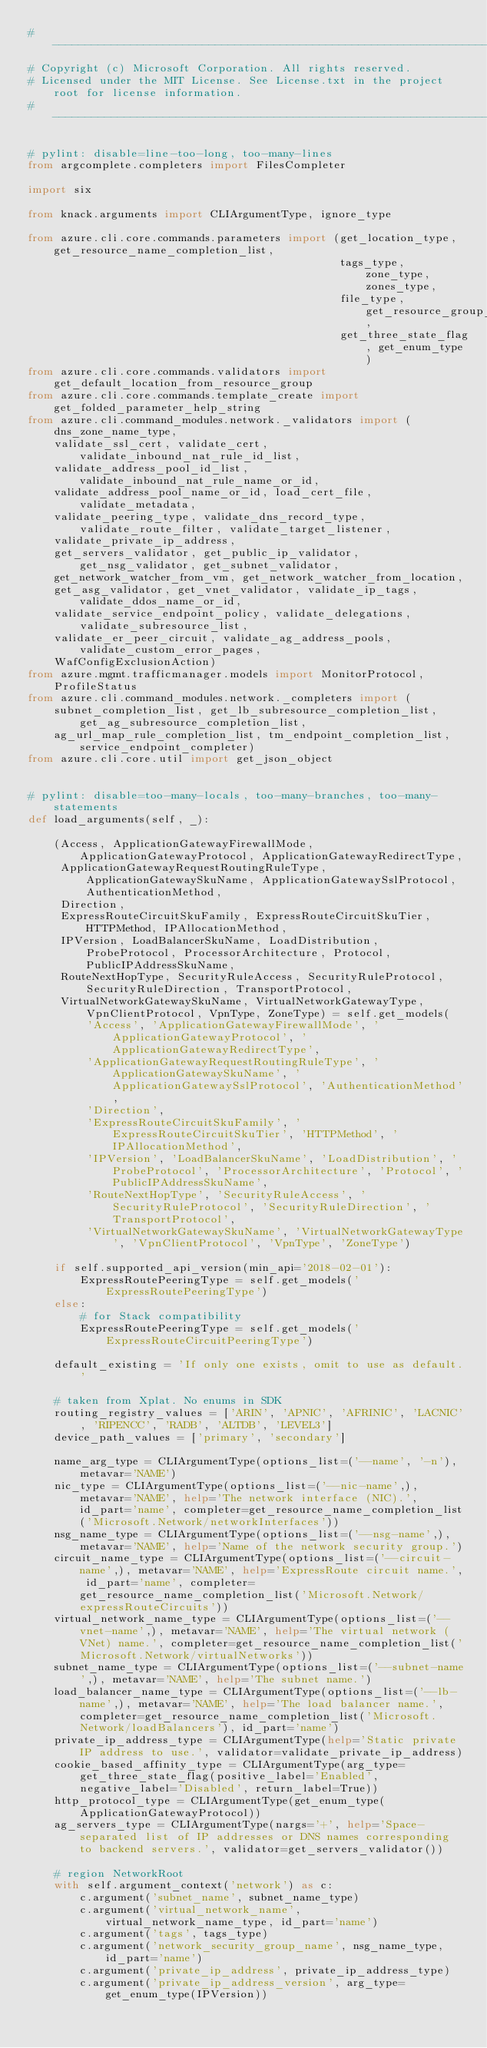Convert code to text. <code><loc_0><loc_0><loc_500><loc_500><_Python_># --------------------------------------------------------------------------------------------
# Copyright (c) Microsoft Corporation. All rights reserved.
# Licensed under the MIT License. See License.txt in the project root for license information.
# --------------------------------------------------------------------------------------------

# pylint: disable=line-too-long, too-many-lines
from argcomplete.completers import FilesCompleter

import six

from knack.arguments import CLIArgumentType, ignore_type

from azure.cli.core.commands.parameters import (get_location_type, get_resource_name_completion_list,
                                                tags_type, zone_type, zones_type,
                                                file_type, get_resource_group_completion_list,
                                                get_three_state_flag, get_enum_type)
from azure.cli.core.commands.validators import get_default_location_from_resource_group
from azure.cli.core.commands.template_create import get_folded_parameter_help_string
from azure.cli.command_modules.network._validators import (
    dns_zone_name_type,
    validate_ssl_cert, validate_cert, validate_inbound_nat_rule_id_list,
    validate_address_pool_id_list, validate_inbound_nat_rule_name_or_id,
    validate_address_pool_name_or_id, load_cert_file, validate_metadata,
    validate_peering_type, validate_dns_record_type, validate_route_filter, validate_target_listener,
    validate_private_ip_address,
    get_servers_validator, get_public_ip_validator, get_nsg_validator, get_subnet_validator,
    get_network_watcher_from_vm, get_network_watcher_from_location,
    get_asg_validator, get_vnet_validator, validate_ip_tags, validate_ddos_name_or_id,
    validate_service_endpoint_policy, validate_delegations, validate_subresource_list,
    validate_er_peer_circuit, validate_ag_address_pools, validate_custom_error_pages,
    WafConfigExclusionAction)
from azure.mgmt.trafficmanager.models import MonitorProtocol, ProfileStatus
from azure.cli.command_modules.network._completers import (
    subnet_completion_list, get_lb_subresource_completion_list, get_ag_subresource_completion_list,
    ag_url_map_rule_completion_list, tm_endpoint_completion_list, service_endpoint_completer)
from azure.cli.core.util import get_json_object


# pylint: disable=too-many-locals, too-many-branches, too-many-statements
def load_arguments(self, _):

    (Access, ApplicationGatewayFirewallMode, ApplicationGatewayProtocol, ApplicationGatewayRedirectType,
     ApplicationGatewayRequestRoutingRuleType, ApplicationGatewaySkuName, ApplicationGatewaySslProtocol, AuthenticationMethod,
     Direction,
     ExpressRouteCircuitSkuFamily, ExpressRouteCircuitSkuTier, HTTPMethod, IPAllocationMethod,
     IPVersion, LoadBalancerSkuName, LoadDistribution, ProbeProtocol, ProcessorArchitecture, Protocol, PublicIPAddressSkuName,
     RouteNextHopType, SecurityRuleAccess, SecurityRuleProtocol, SecurityRuleDirection, TransportProtocol,
     VirtualNetworkGatewaySkuName, VirtualNetworkGatewayType, VpnClientProtocol, VpnType, ZoneType) = self.get_models(
         'Access', 'ApplicationGatewayFirewallMode', 'ApplicationGatewayProtocol', 'ApplicationGatewayRedirectType',
         'ApplicationGatewayRequestRoutingRuleType', 'ApplicationGatewaySkuName', 'ApplicationGatewaySslProtocol', 'AuthenticationMethod',
         'Direction',
         'ExpressRouteCircuitSkuFamily', 'ExpressRouteCircuitSkuTier', 'HTTPMethod', 'IPAllocationMethod',
         'IPVersion', 'LoadBalancerSkuName', 'LoadDistribution', 'ProbeProtocol', 'ProcessorArchitecture', 'Protocol', 'PublicIPAddressSkuName',
         'RouteNextHopType', 'SecurityRuleAccess', 'SecurityRuleProtocol', 'SecurityRuleDirection', 'TransportProtocol',
         'VirtualNetworkGatewaySkuName', 'VirtualNetworkGatewayType', 'VpnClientProtocol', 'VpnType', 'ZoneType')

    if self.supported_api_version(min_api='2018-02-01'):
        ExpressRoutePeeringType = self.get_models('ExpressRoutePeeringType')
    else:
        # for Stack compatibility
        ExpressRoutePeeringType = self.get_models('ExpressRouteCircuitPeeringType')

    default_existing = 'If only one exists, omit to use as default.'

    # taken from Xplat. No enums in SDK
    routing_registry_values = ['ARIN', 'APNIC', 'AFRINIC', 'LACNIC', 'RIPENCC', 'RADB', 'ALTDB', 'LEVEL3']
    device_path_values = ['primary', 'secondary']

    name_arg_type = CLIArgumentType(options_list=('--name', '-n'), metavar='NAME')
    nic_type = CLIArgumentType(options_list=('--nic-name',), metavar='NAME', help='The network interface (NIC).', id_part='name', completer=get_resource_name_completion_list('Microsoft.Network/networkInterfaces'))
    nsg_name_type = CLIArgumentType(options_list=('--nsg-name',), metavar='NAME', help='Name of the network security group.')
    circuit_name_type = CLIArgumentType(options_list=('--circuit-name',), metavar='NAME', help='ExpressRoute circuit name.', id_part='name', completer=get_resource_name_completion_list('Microsoft.Network/expressRouteCircuits'))
    virtual_network_name_type = CLIArgumentType(options_list=('--vnet-name',), metavar='NAME', help='The virtual network (VNet) name.', completer=get_resource_name_completion_list('Microsoft.Network/virtualNetworks'))
    subnet_name_type = CLIArgumentType(options_list=('--subnet-name',), metavar='NAME', help='The subnet name.')
    load_balancer_name_type = CLIArgumentType(options_list=('--lb-name',), metavar='NAME', help='The load balancer name.', completer=get_resource_name_completion_list('Microsoft.Network/loadBalancers'), id_part='name')
    private_ip_address_type = CLIArgumentType(help='Static private IP address to use.', validator=validate_private_ip_address)
    cookie_based_affinity_type = CLIArgumentType(arg_type=get_three_state_flag(positive_label='Enabled', negative_label='Disabled', return_label=True))
    http_protocol_type = CLIArgumentType(get_enum_type(ApplicationGatewayProtocol))
    ag_servers_type = CLIArgumentType(nargs='+', help='Space-separated list of IP addresses or DNS names corresponding to backend servers.', validator=get_servers_validator())

    # region NetworkRoot
    with self.argument_context('network') as c:
        c.argument('subnet_name', subnet_name_type)
        c.argument('virtual_network_name', virtual_network_name_type, id_part='name')
        c.argument('tags', tags_type)
        c.argument('network_security_group_name', nsg_name_type, id_part='name')
        c.argument('private_ip_address', private_ip_address_type)
        c.argument('private_ip_address_version', arg_type=get_enum_type(IPVersion))</code> 